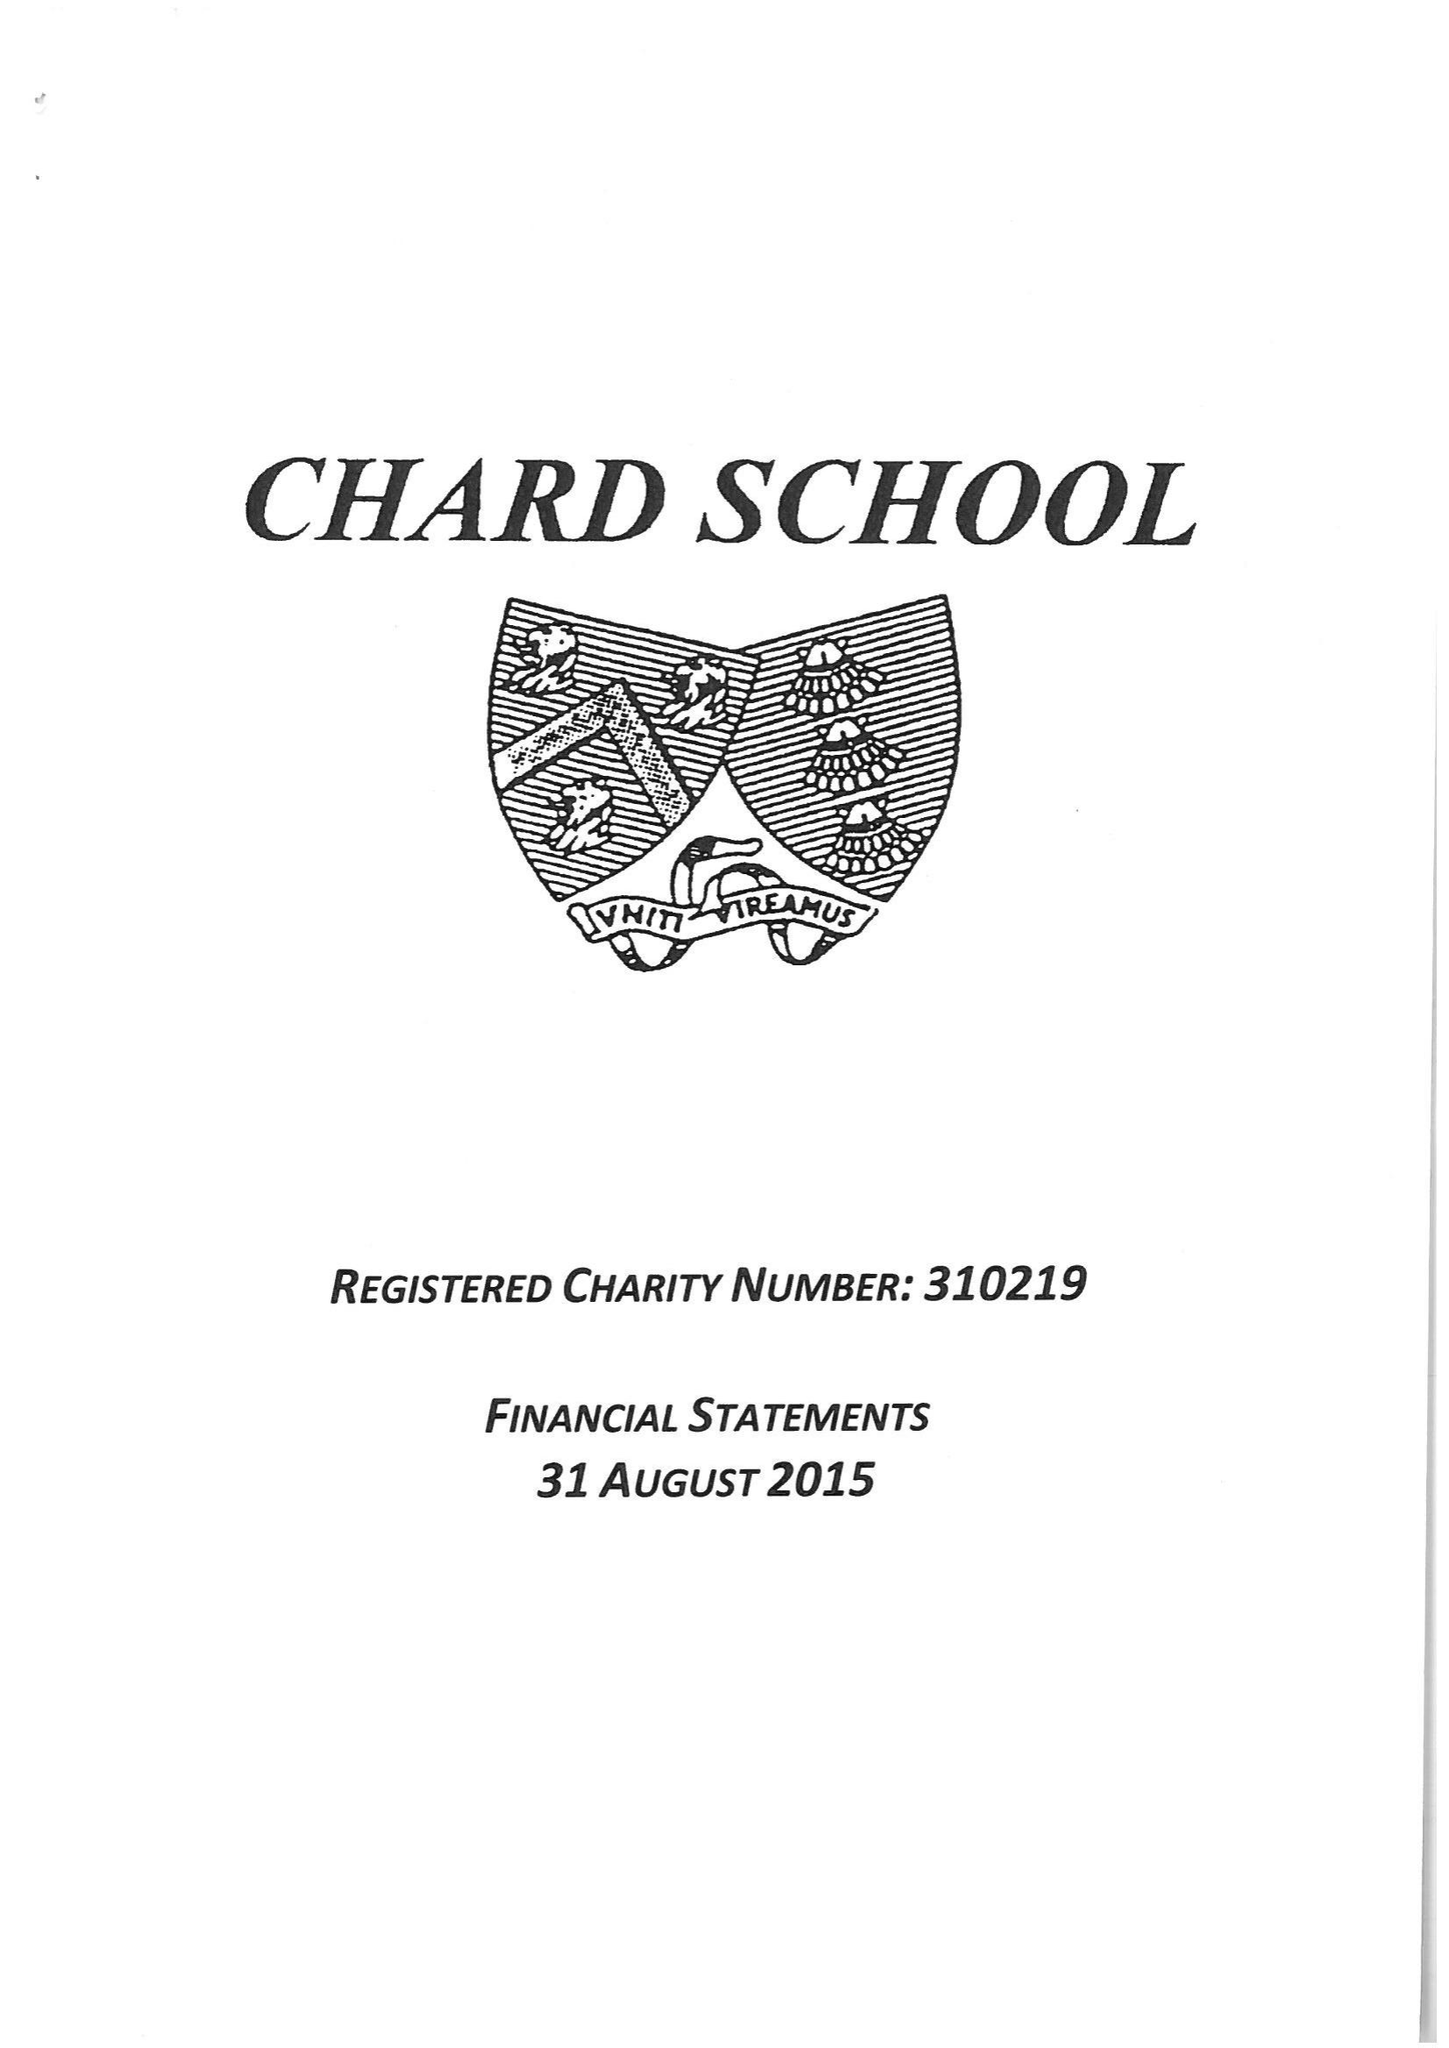What is the value for the report_date?
Answer the question using a single word or phrase. 2015-08-31 